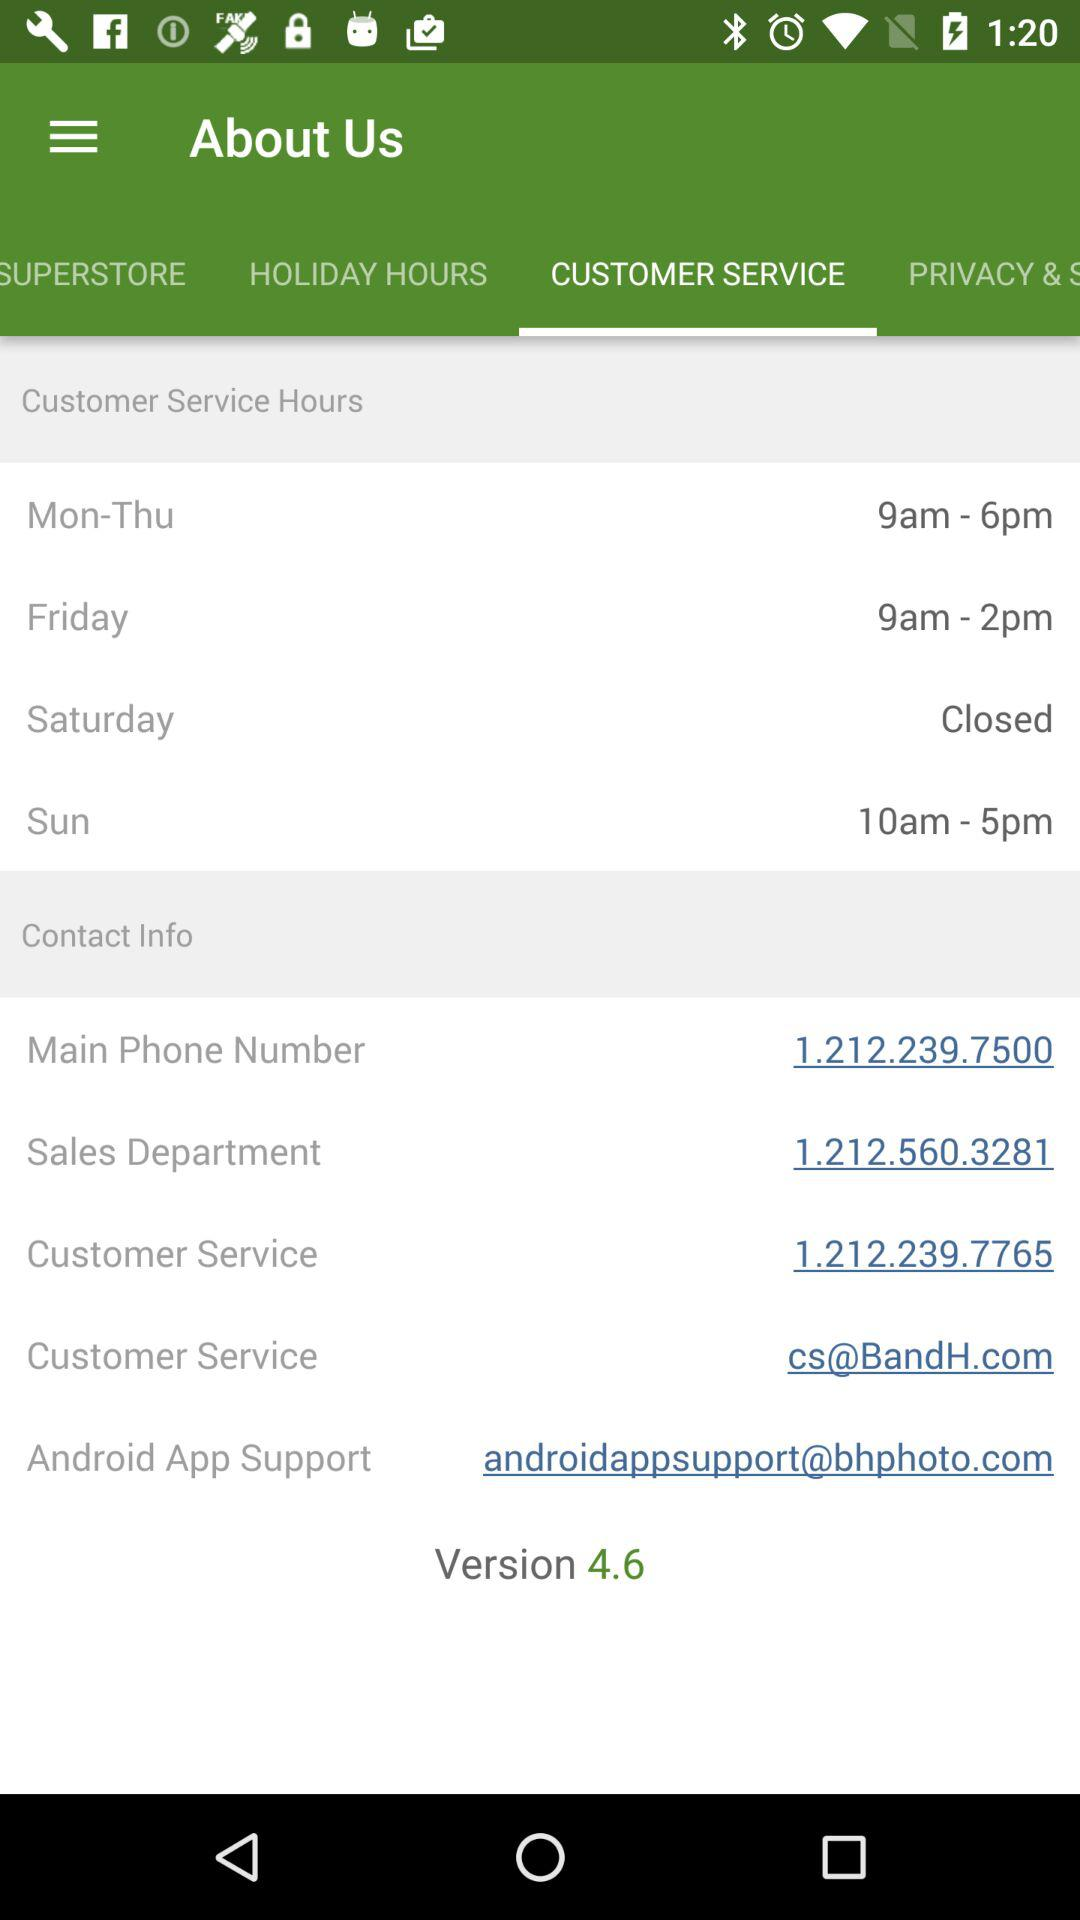What is the email address of android support? The email address is androidappsupport@bhphoto.com. 